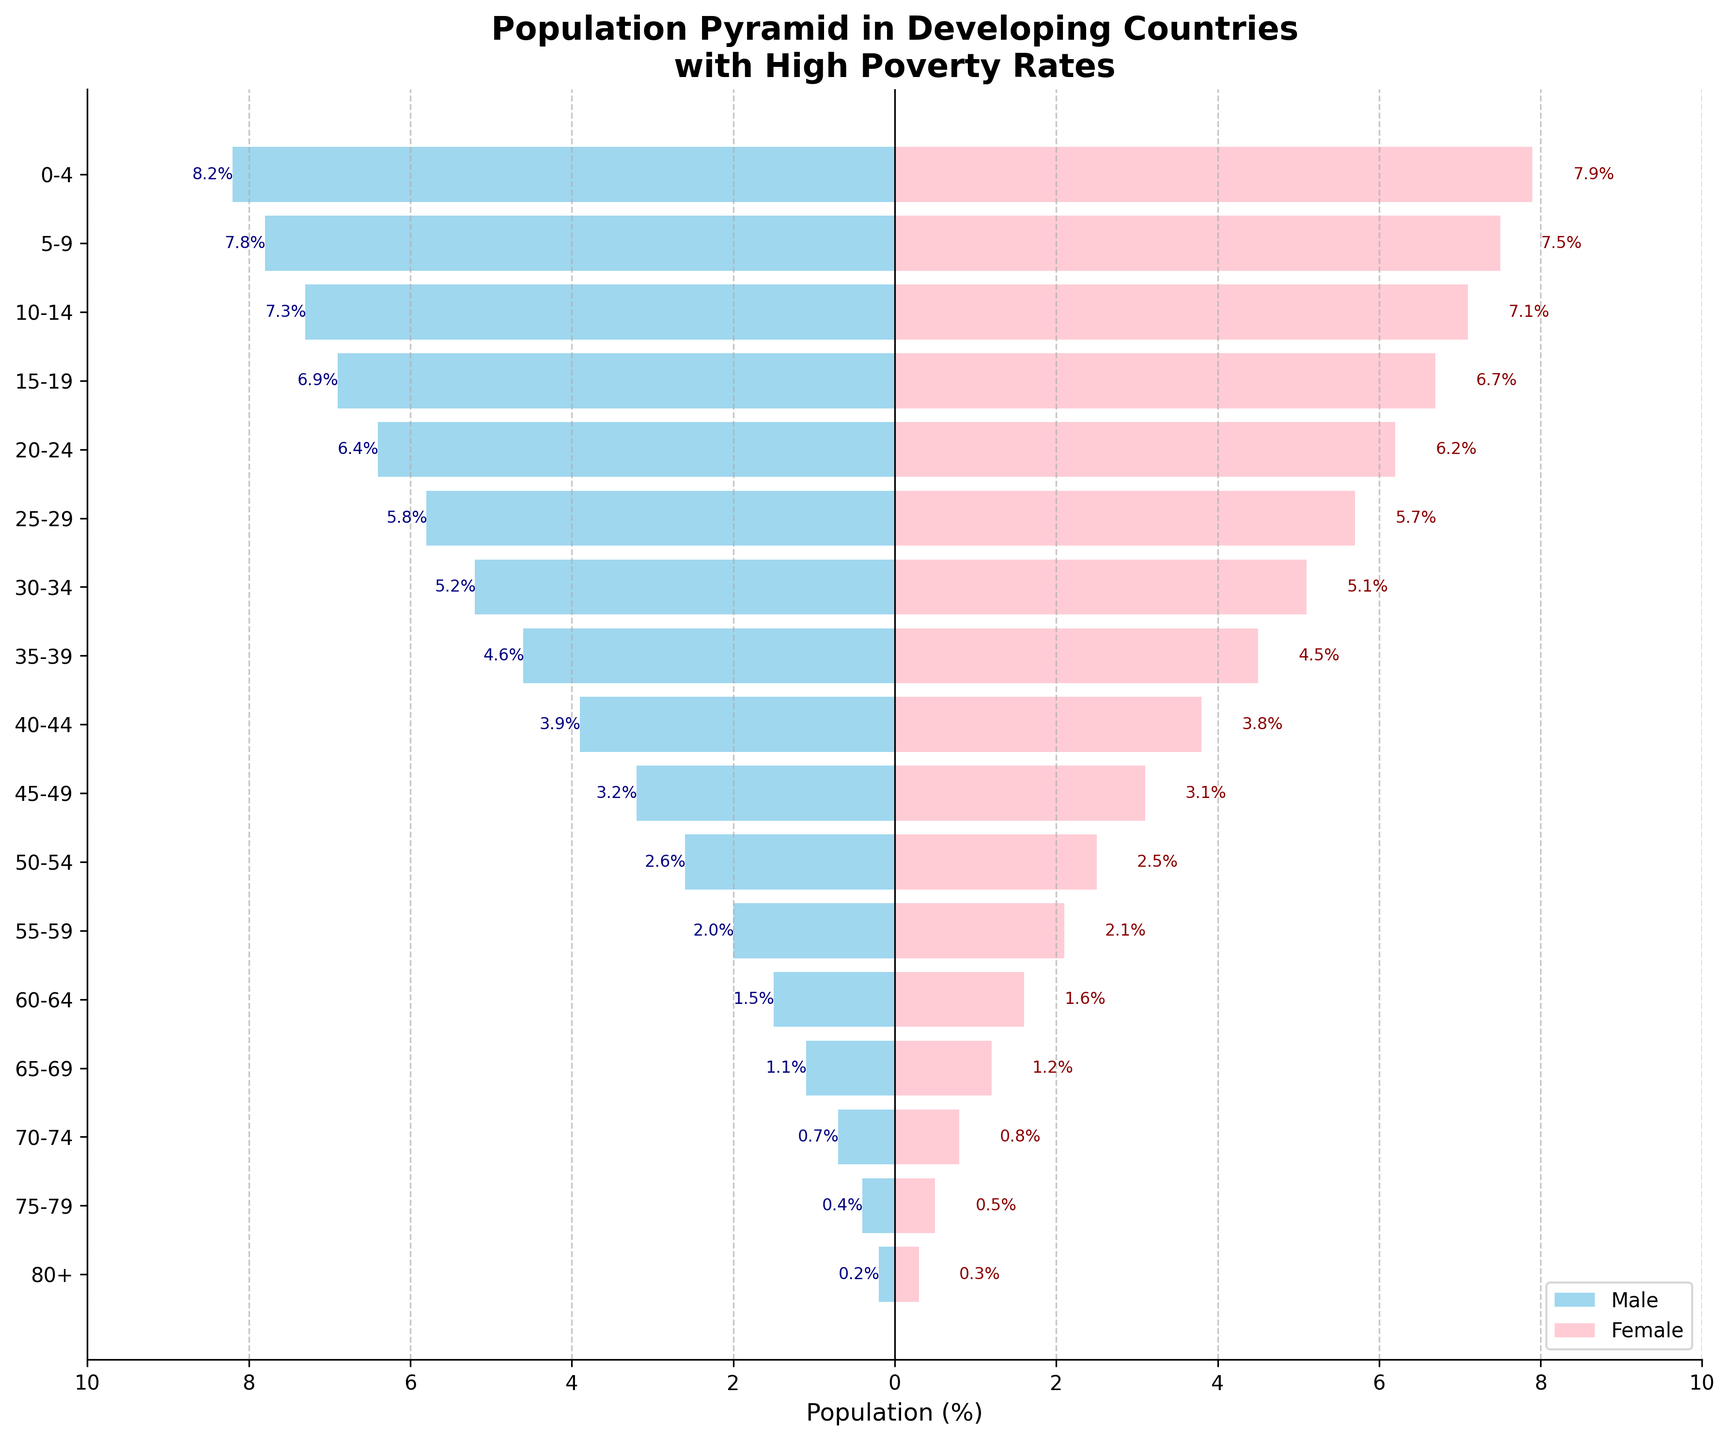How are the population percentages distributed across different age groups for both genders? The figure displays horizontal bars for age groups, with percentages to the left for males and to the right for females.
Answer: Distributed in increasing percentages from older to younger age groups What is the percentage of males aged 0-4 compared to females in the same group? By looking at the bars corresponding to age 0-4, the percentage for males is 8.2%, and for females, it is 7.9%.
Answer: Males: 8.2%, Females: 7.9% Which age group has the smallest population percentage for both males and females? The smallest bars for both males and females are found in the 80+ age group.
Answer: 80+ age group What is the male population percentage for the age group 70-74? Locate the bars for the 70-74 age group and refer to the value on the left side for males.
Answer: 0.7% Which gender has a higher percentage in the 75-79 age group, and by how much? Compare the lengths of the bars for the 75-79 age group. Females have a higher percentage (0.5%) compared to males (0.4%).
Answer: Females by 0.1% What is the difference in population percentage between males and females for ages 40-44? For the 40-44 age group, the male population percentage is 3.9% and the female population percentage is 3.8%. The difference is 3.9% - 3.8%.
Answer: 0.1% How does the population distribution for the age group 30-34 compare with 50-54 for both genders? For the 30-34 age group, males represent 5.2% and females 5.1%. For 50-54, males represent 2.6% and females 2.5%. The younger group has a higher percentage.
Answer: 30-34 has a higher percentage for both genders Are there any age groups where females have a higher population percentage than males? If so, which ones? Scan through the segments for females to see if any bar lengths exceed their male counterparts. This occurs in the age groups 55-59, 60-64, 65-69, 70-74, 75-79, and 80+.
Answer: 55-59, 60-64, 65-69, 70-74, 75-79, 80+ What is the total population percentage for both genders combined in the age group 25-29? Combine the population percentages for males (5.8%) and females (5.7%).
Answer: 11.5% Which age group has the most significant gender disparity in population percentages, and what is the difference? Identify age groups with visible disparities and find the explicit difference. The 0-4 age group shows a noticeable gap (8.2% males vs. 7.9% females).
Answer: 0-4, with a difference of 0.3% 